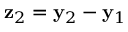Convert formula to latex. <formula><loc_0><loc_0><loc_500><loc_500>{ z } _ { 2 } = { y } _ { 2 } - { y } _ { 1 }</formula> 